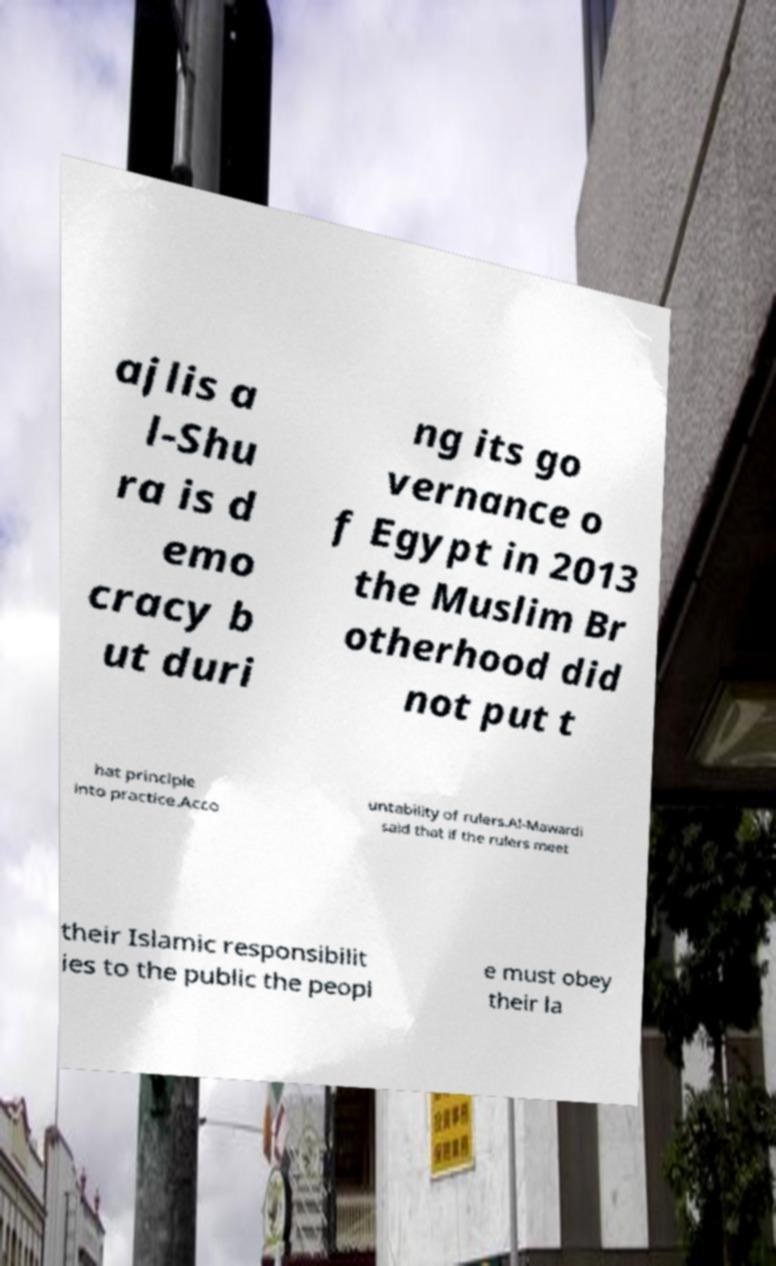Please read and relay the text visible in this image. What does it say? ajlis a l-Shu ra is d emo cracy b ut duri ng its go vernance o f Egypt in 2013 the Muslim Br otherhood did not put t hat principle into practice.Acco untability of rulers.Al-Mawardi said that if the rulers meet their Islamic responsibilit ies to the public the peopl e must obey their la 